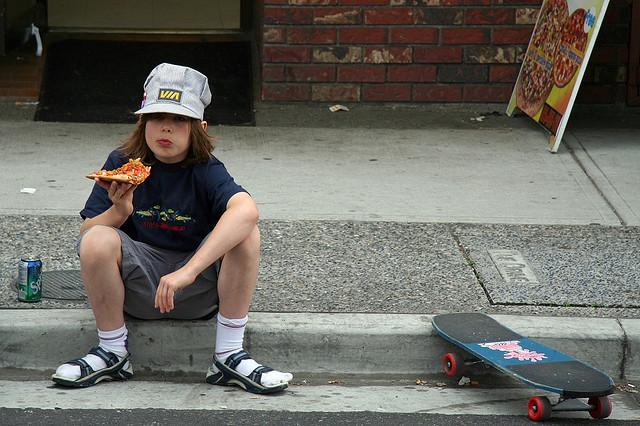What type of shoes is the child wearing?
Keep it brief. Sandals. Is this person catching his balance?
Be succinct. No. How many people in the picture?
Keep it brief. 1. Can the boy ride?
Be succinct. Yes. What is this kid eating?
Keep it brief. Pizza. Is this little girl dressed for summer?
Keep it brief. Yes. Why should the skateboarder wait before proceeding?
Give a very brief answer. Eating. Why is she sitting on the floor?
Keep it brief. Eating. What is the child sitting on?
Quick response, please. Curb. Do you think the child is enjoying his/her food?
Quick response, please. Yes. What kind of shoes are these?
Keep it brief. Sandals. What does he have under his feet?
Keep it brief. Sandals. 